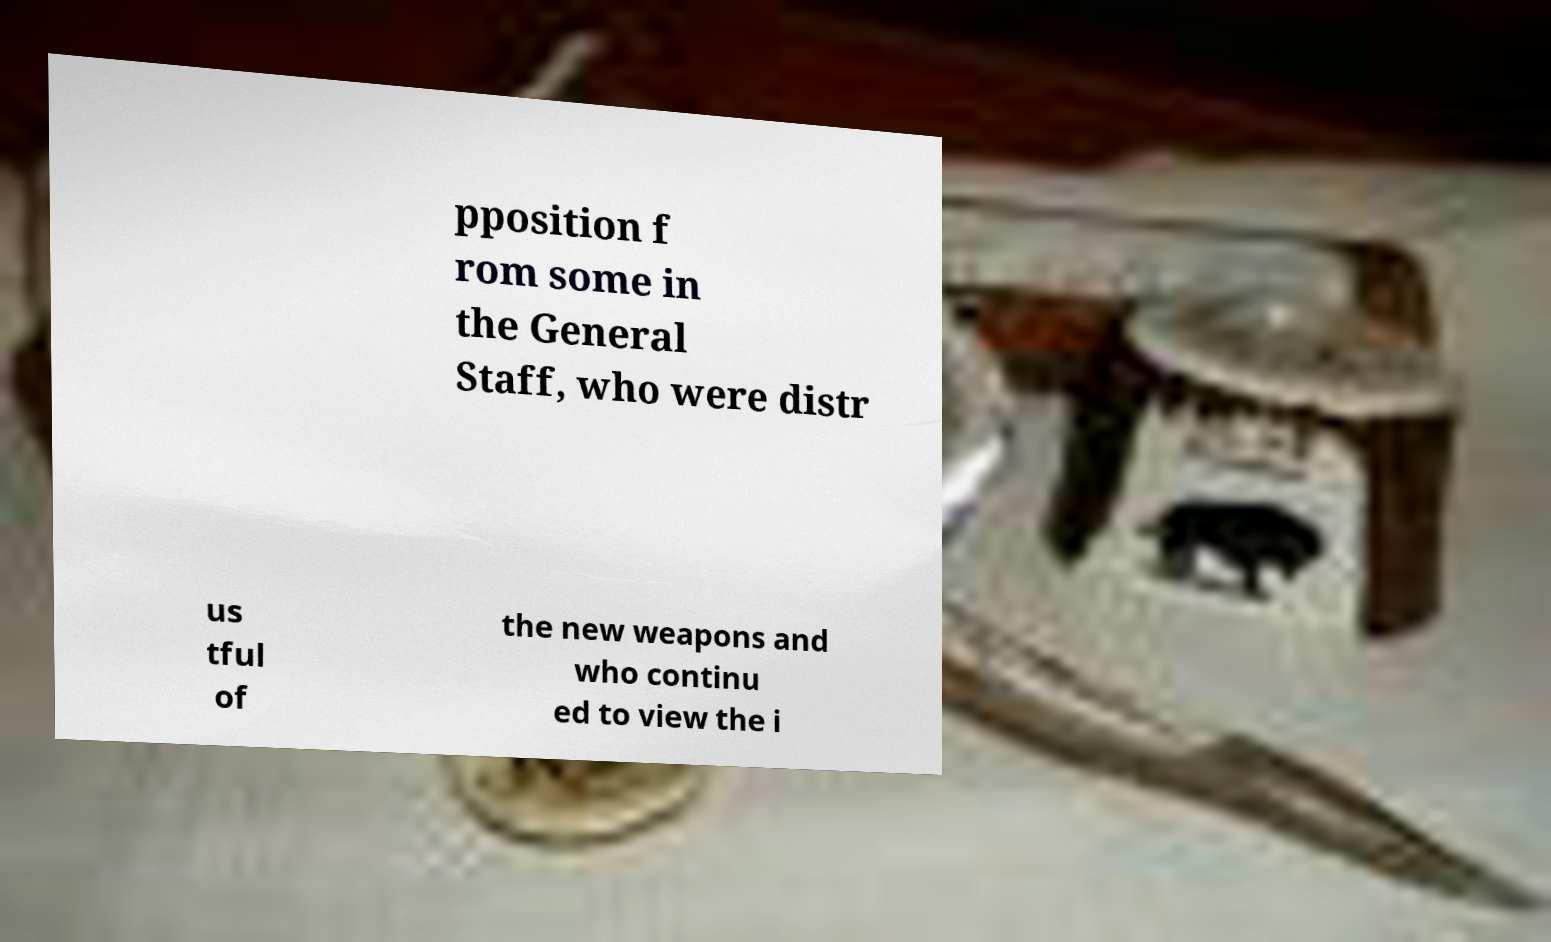There's text embedded in this image that I need extracted. Can you transcribe it verbatim? pposition f rom some in the General Staff, who were distr us tful of the new weapons and who continu ed to view the i 